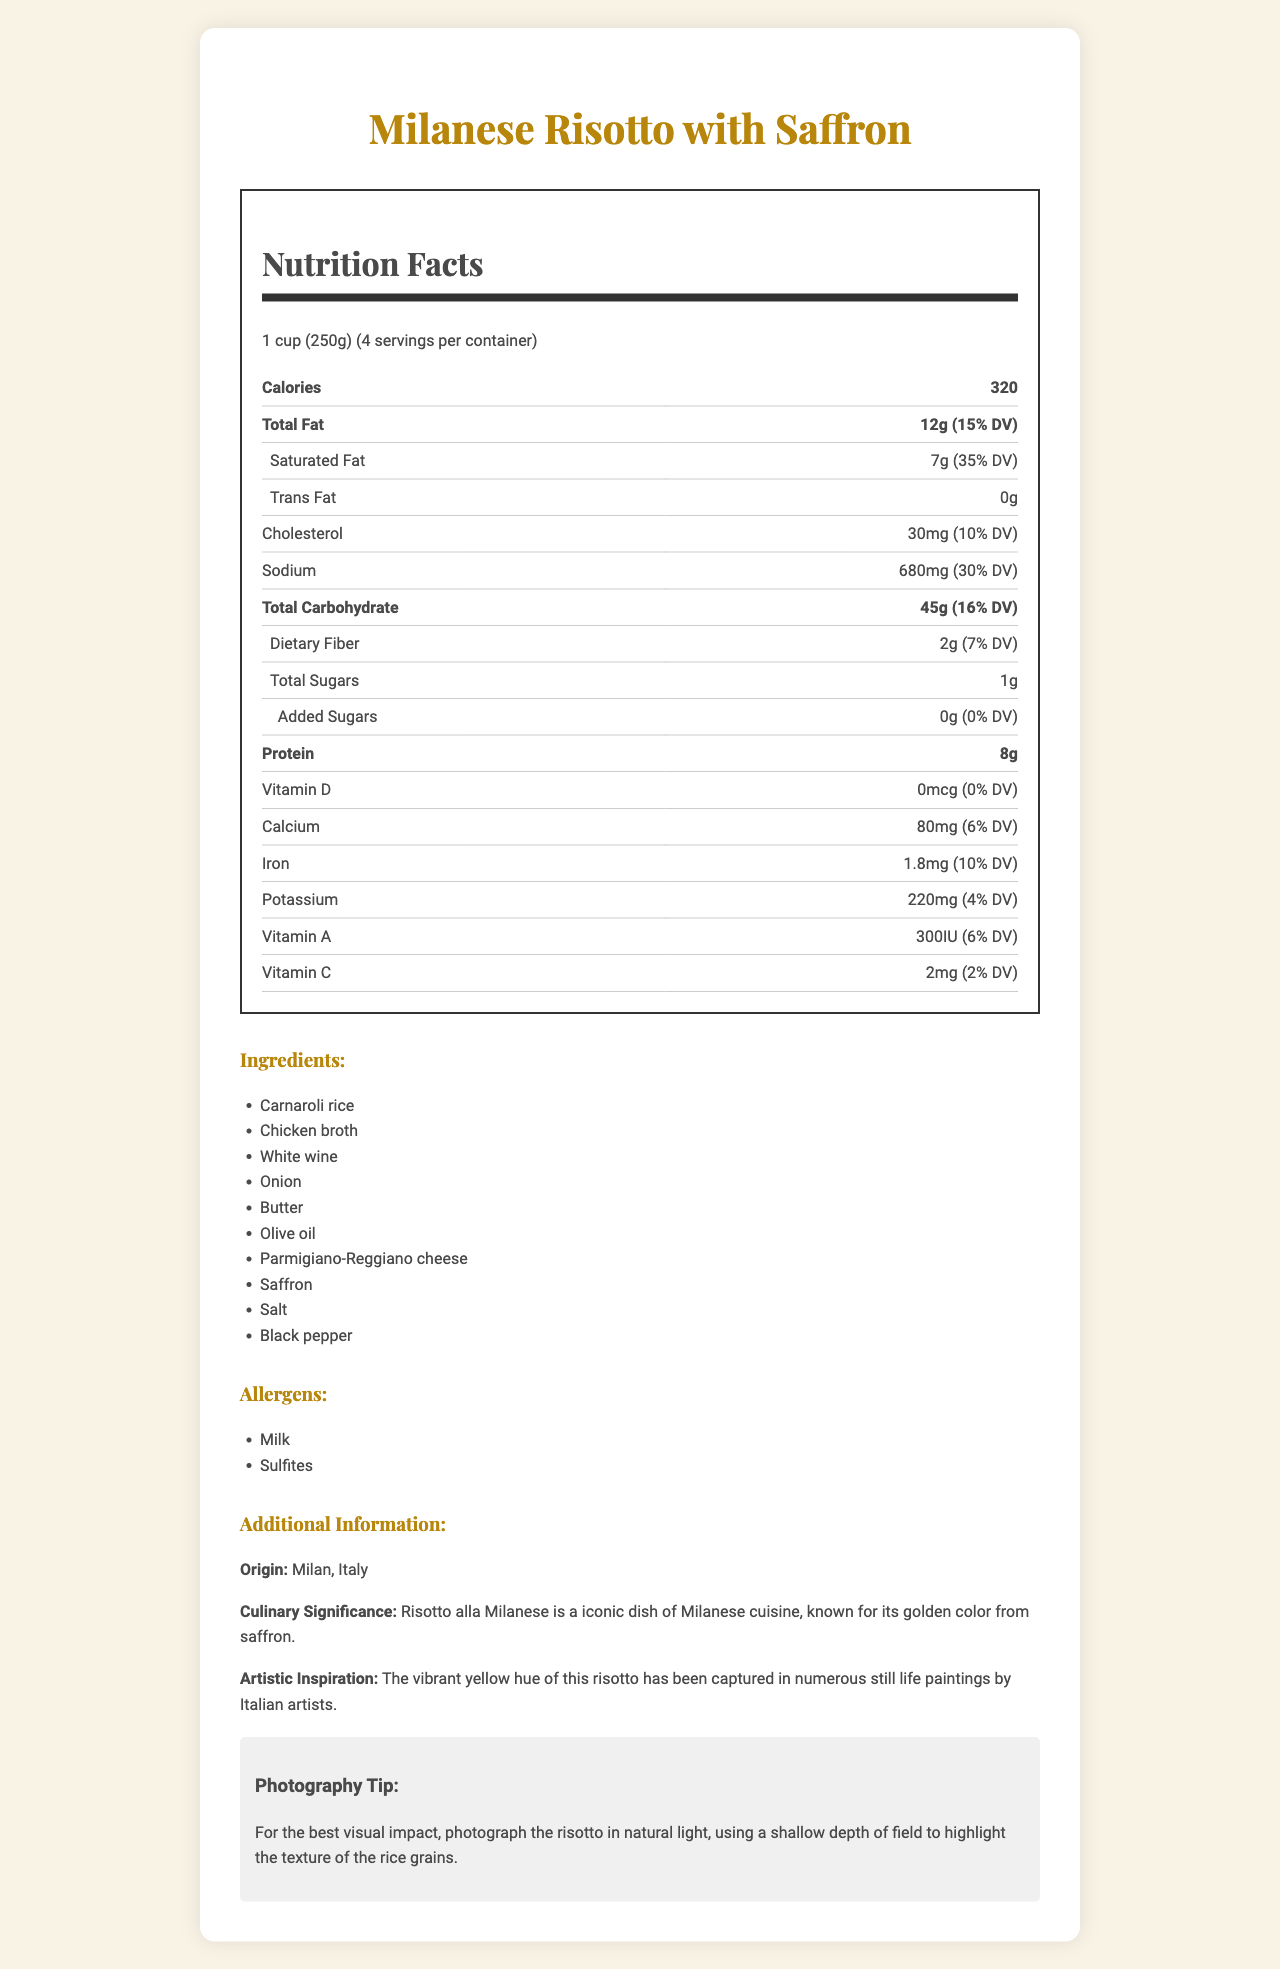what is the serving size? The serving size is stated at the very beginning of the nutrition label.
Answer: 1 cup (250g) how many calories per serving? The number of calories per serving is located in the prominent section of the nutrition facts.
Answer: 320 how many servings are in the container? The label specifies that there are 4 servings per container.
Answer: 4 what is the total fat content per serving? The total fat content is clearly mentioned as 12g.
Answer: 12g how much sodium does one serving contain? The amount of sodium per serving is 680mg according to the nutrition facts.
Answer: 680mg which allergens are present in the risotto? A. Milk and Gluten B. Sulfites and Nuts C. Milk and Sulfites D. Gluten and Nuts The allergens listed are Milk and Sulfites.
Answer: C what is the percentage daily value of saturated fat? A. 15% B. 35% C. 10% D. 25% The percentage daily value of saturated fat is indicated as 35%.
Answer: B is there any trans fat in the risotto? The document states that there is 0g of trans fat.
Answer: No does the risotto contain added sugars? The nutrition facts specify that there are 0g of added sugars.
Answer: No what is the origin of the dish? The additional information section states the origin of the dish as Milan, Italy.
Answer: Milan, Italy what artistic significance is associated with this dish? According to the additional information, this dish's color has inspired many Italian still life paintings.
Answer: The vibrant yellow hue of this risotto has been captured in numerous still life paintings by Italian artists. what tip is provided for photographing the risotto? The document provides a specific tip for photographing the risotto to highlight its texture.
Answer: For the best visual impact, photograph the risotto in natural light, using a shallow depth of field to highlight the texture of the rice grains. describe the main point of the document. The document summarizes nutritional details and cultural significance of the Milanese Risotto with Saffron, including a photography tip for capturing its essence visually.
Answer: The document provides nutrition facts, ingredients, allergens, and additional information about Milanese Risotto with Saffron, emphasizing its cultural and artistic significance and offering a photography tip. what is the vitamin D content of the risotto? The nutrition label indicates that the vitamin D content is 0 mcg.
Answer: 0 mcg how much protein is in one serving? The protein content per serving is specified as 8g.
Answer: 8g can you determine the exact quantity of saffron used in this recipe? The document lists saffron as an ingredient but does not specify the exact quantity used.
Answer: Cannot be determined 